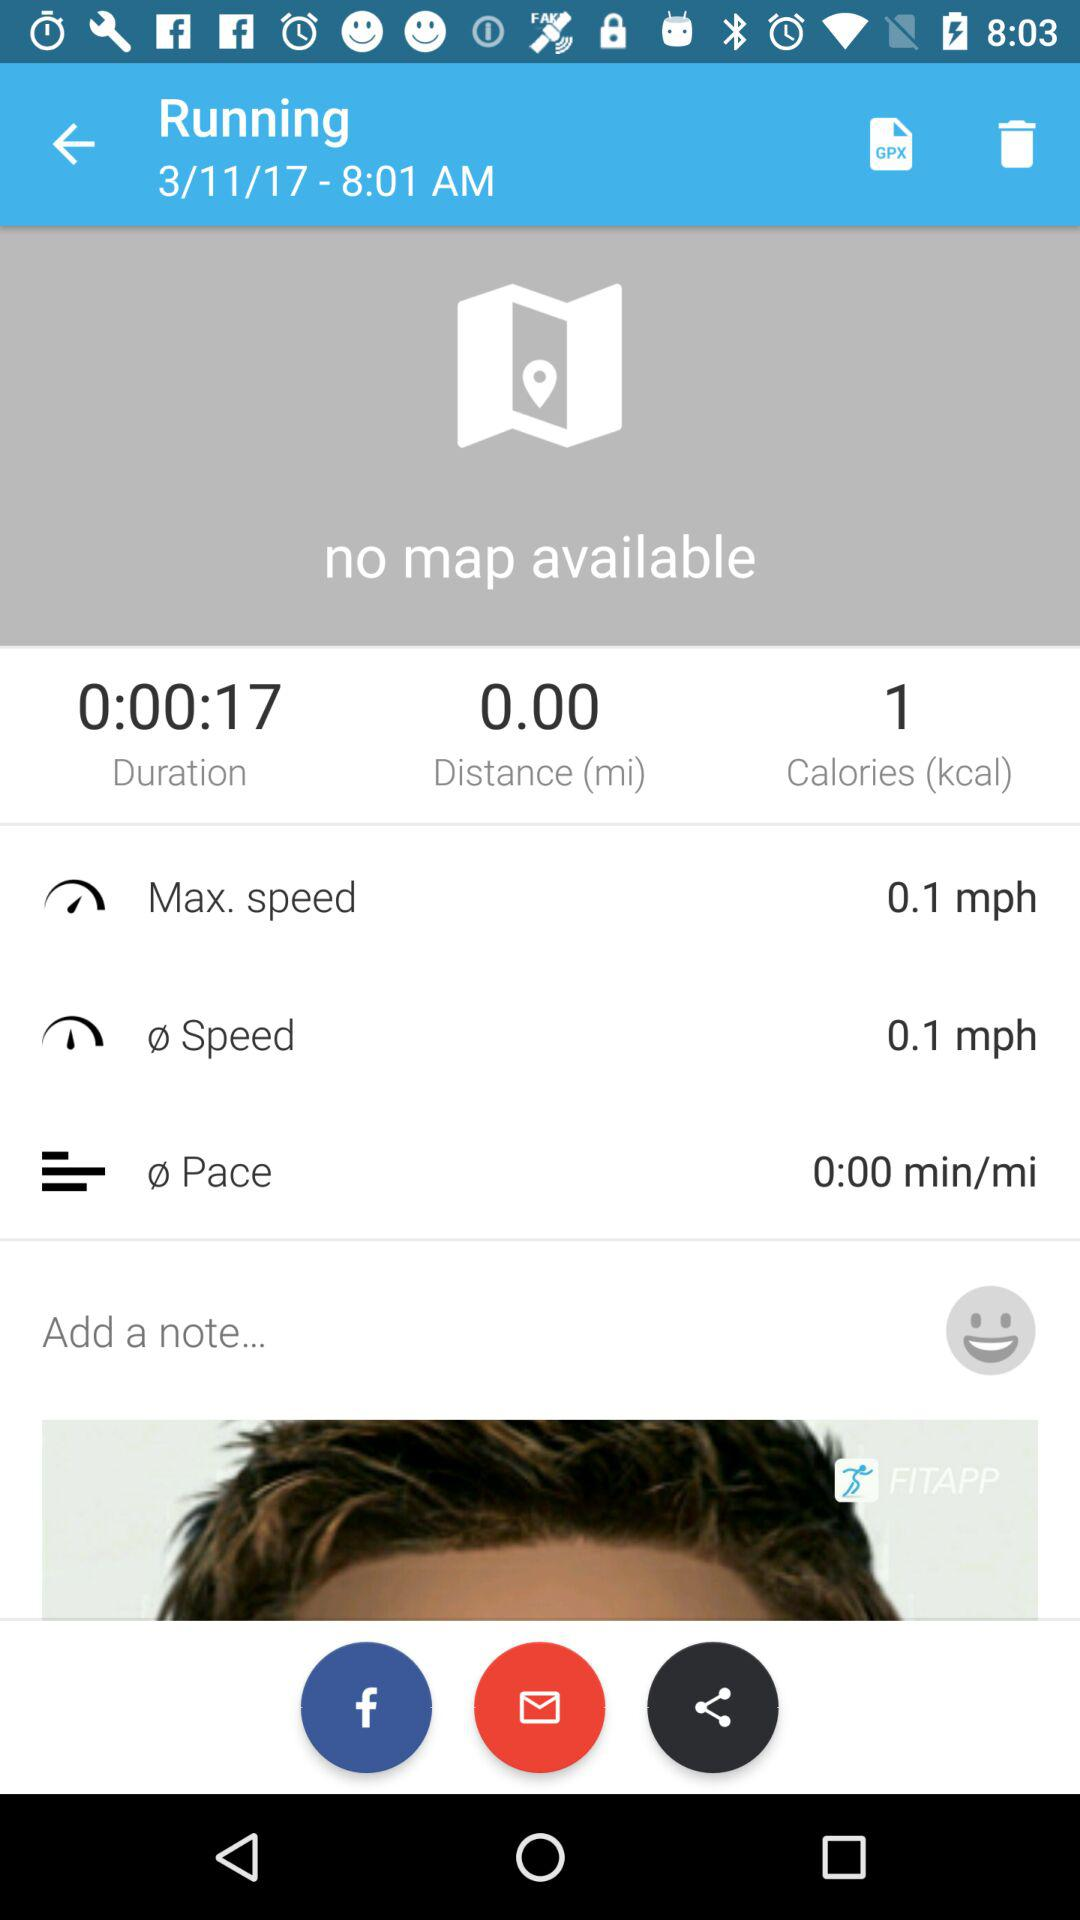What is the pace? The pace is 0 minutes per mile. 